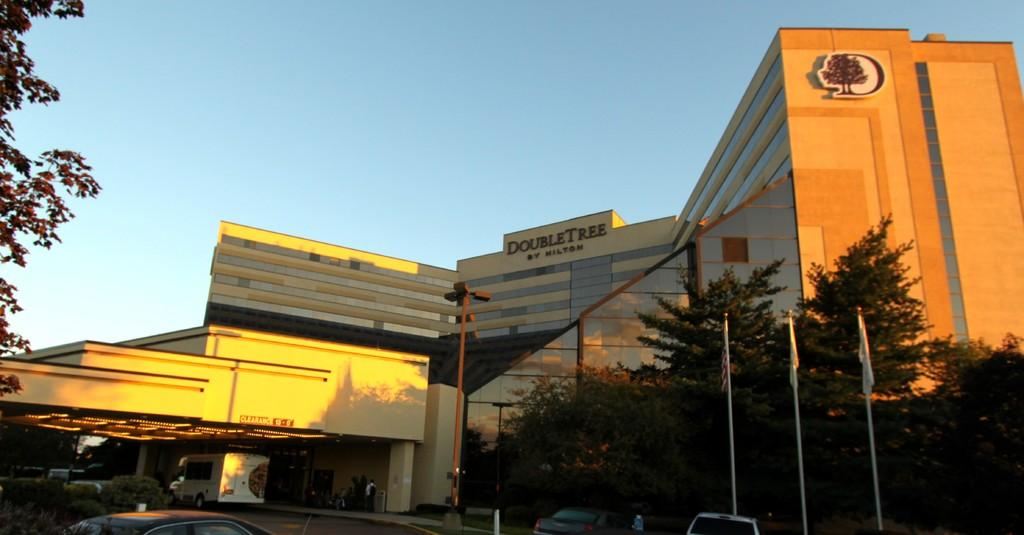What is located in the foreground of the image? There is a building, trees, vehicles, and poles in the foreground of the image. Can you describe the vegetation in the foreground of the image? There are trees in the foreground of the image. What type of man-made structures can be seen in the foreground of the image? There is a building and poles visible in the foreground of the image. What is visible at the top of the image? The sky is visible at the top of the image. What type of feast is being held in the image? There is no feast present in the image; it features a building, trees, vehicles, and poles in the foreground, and the sky at the top. What shape is the town in the image? There is no town present in the image, so it is not possible to determine its shape. 